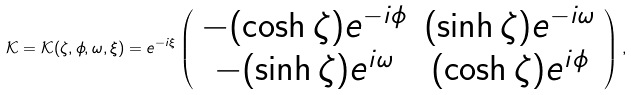Convert formula to latex. <formula><loc_0><loc_0><loc_500><loc_500>\mathcal { K } = \mathcal { K } ( \zeta , \phi , \omega , \xi ) = e ^ { - i \xi } \left ( \begin{array} { c c } - ( \cosh \zeta ) e ^ { - i \phi } & ( \sinh \zeta ) e ^ { - i \omega } \\ - ( \sinh \zeta ) e ^ { i \omega } & ( \cosh \zeta ) e ^ { i \phi } \end{array} \right ) ,</formula> 